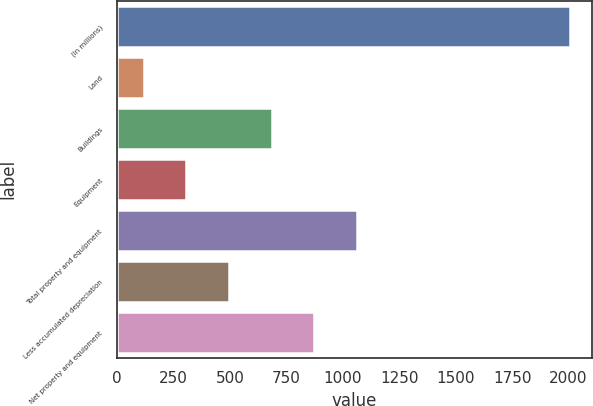Convert chart to OTSL. <chart><loc_0><loc_0><loc_500><loc_500><bar_chart><fcel>(In millions)<fcel>Land<fcel>Buildings<fcel>Equipment<fcel>Total property and equipment<fcel>Less accumulated depreciation<fcel>Net property and equipment<nl><fcel>2005<fcel>119<fcel>684.8<fcel>307.6<fcel>1062<fcel>496.2<fcel>873.4<nl></chart> 